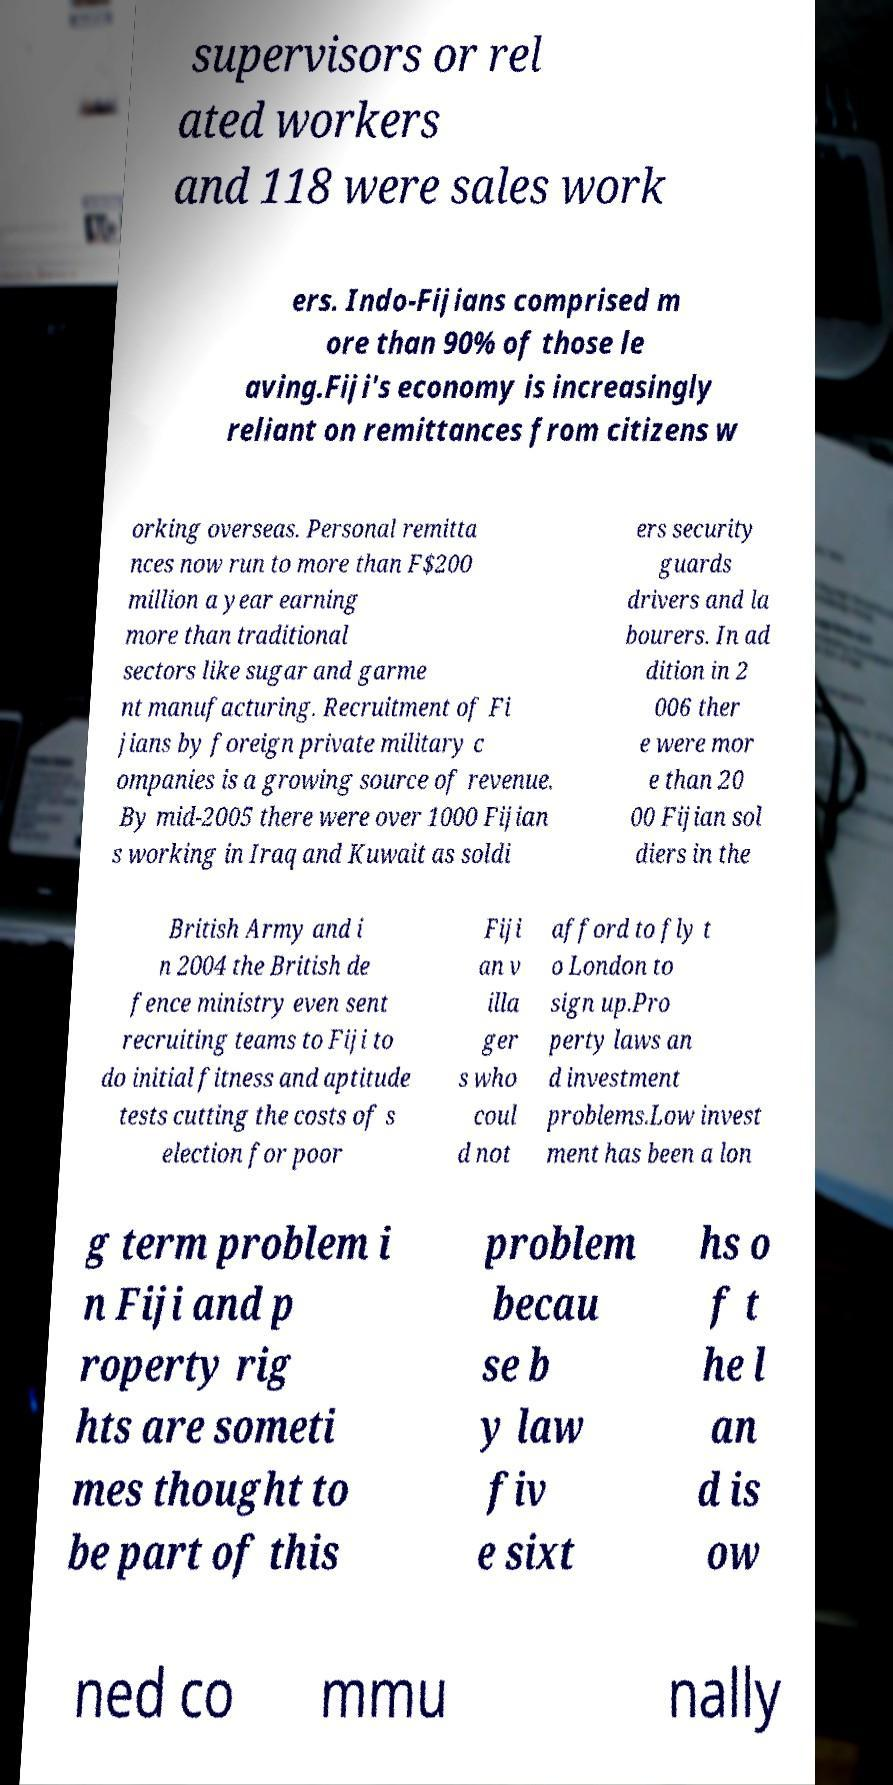Please identify and transcribe the text found in this image. supervisors or rel ated workers and 118 were sales work ers. Indo-Fijians comprised m ore than 90% of those le aving.Fiji's economy is increasingly reliant on remittances from citizens w orking overseas. Personal remitta nces now run to more than F$200 million a year earning more than traditional sectors like sugar and garme nt manufacturing. Recruitment of Fi jians by foreign private military c ompanies is a growing source of revenue. By mid-2005 there were over 1000 Fijian s working in Iraq and Kuwait as soldi ers security guards drivers and la bourers. In ad dition in 2 006 ther e were mor e than 20 00 Fijian sol diers in the British Army and i n 2004 the British de fence ministry even sent recruiting teams to Fiji to do initial fitness and aptitude tests cutting the costs of s election for poor Fiji an v illa ger s who coul d not afford to fly t o London to sign up.Pro perty laws an d investment problems.Low invest ment has been a lon g term problem i n Fiji and p roperty rig hts are someti mes thought to be part of this problem becau se b y law fiv e sixt hs o f t he l an d is ow ned co mmu nally 